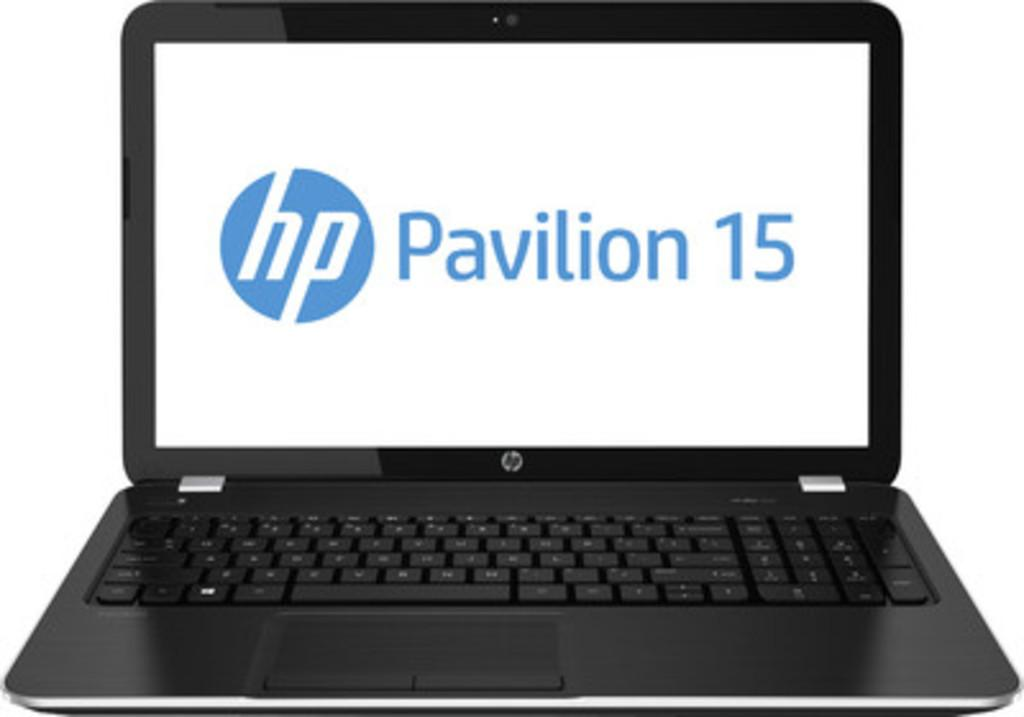<image>
Share a concise interpretation of the image provided. A laptop screen displays the logo for an HP Pavilion 15. 